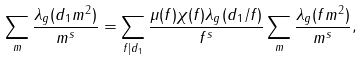<formula> <loc_0><loc_0><loc_500><loc_500>\sum _ { m } \frac { \lambda _ { g } ( d _ { 1 } m ^ { 2 } ) } { m ^ { s } } = \sum _ { f | d _ { 1 } } \frac { \mu ( f ) \chi ( f ) \lambda _ { g } ( d _ { 1 } / f ) } { f ^ { s } } \sum _ { m } \frac { \lambda _ { g } ( f m ^ { 2 } ) } { m ^ { s } } ,</formula> 